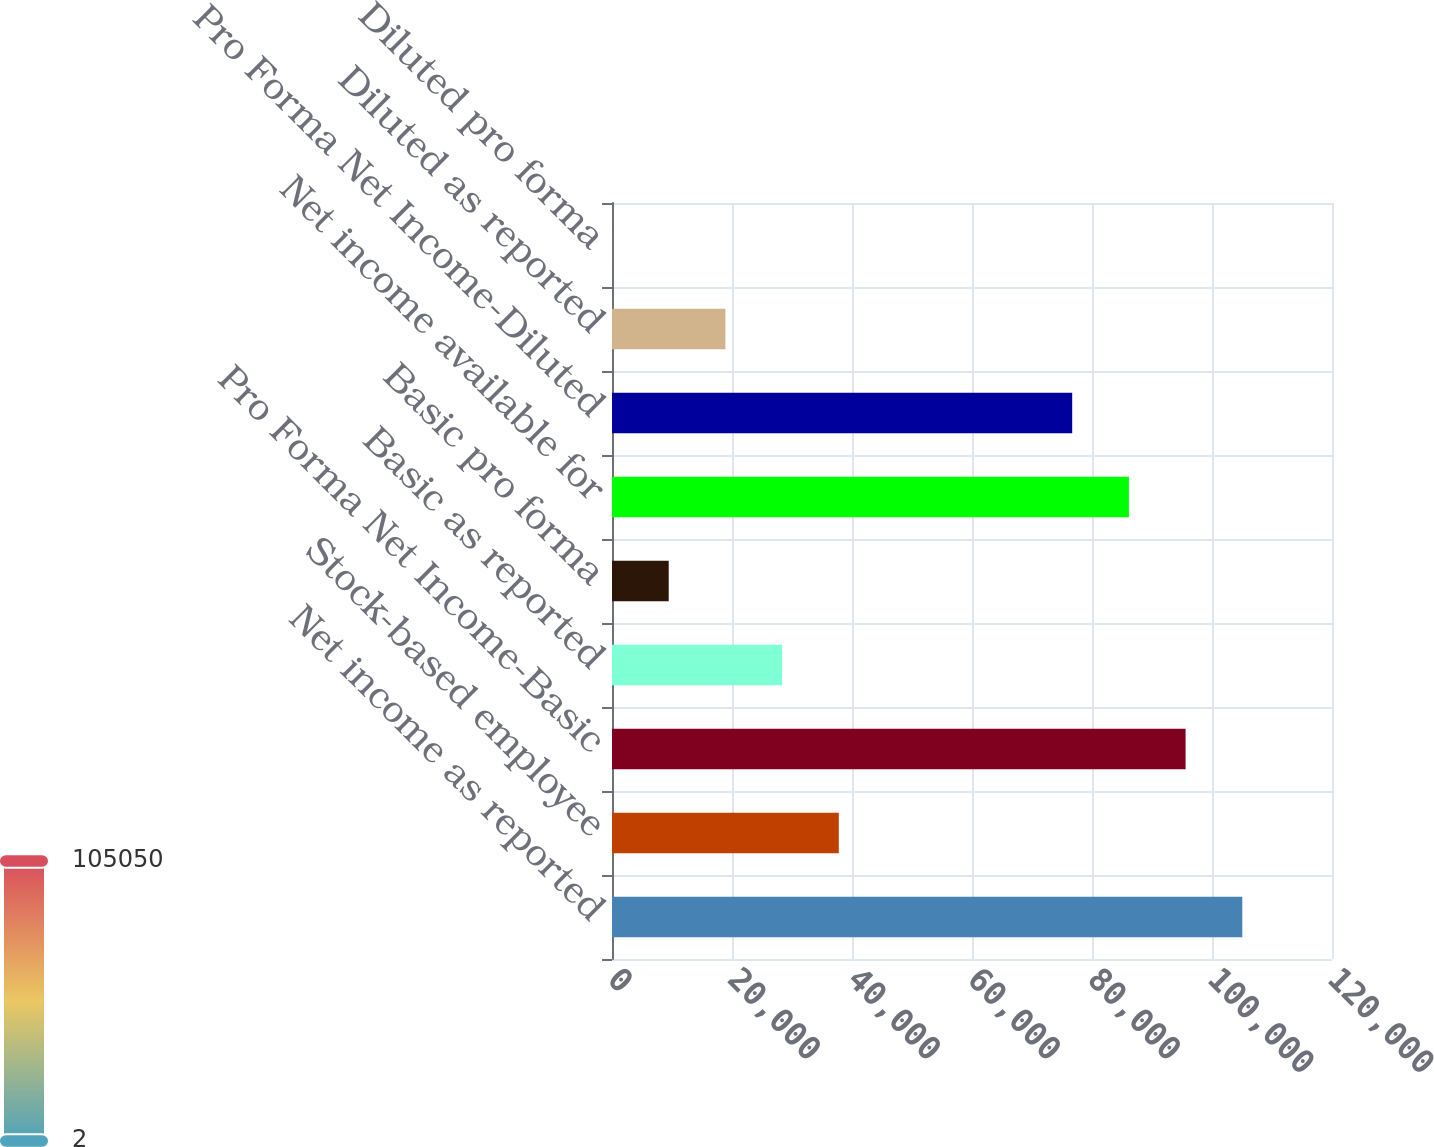<chart> <loc_0><loc_0><loc_500><loc_500><bar_chart><fcel>Net income as reported<fcel>Stock-based employee<fcel>Pro Forma Net Income-Basic<fcel>Basic as reported<fcel>Basic pro forma<fcel>Net income available for<fcel>Pro Forma Net Income-Diluted<fcel>Diluted as reported<fcel>Diluted pro forma<nl><fcel>105050<fcel>37799.7<fcel>95600.1<fcel>28350.2<fcel>9451.12<fcel>86150.5<fcel>76701<fcel>18900.7<fcel>1.58<nl></chart> 